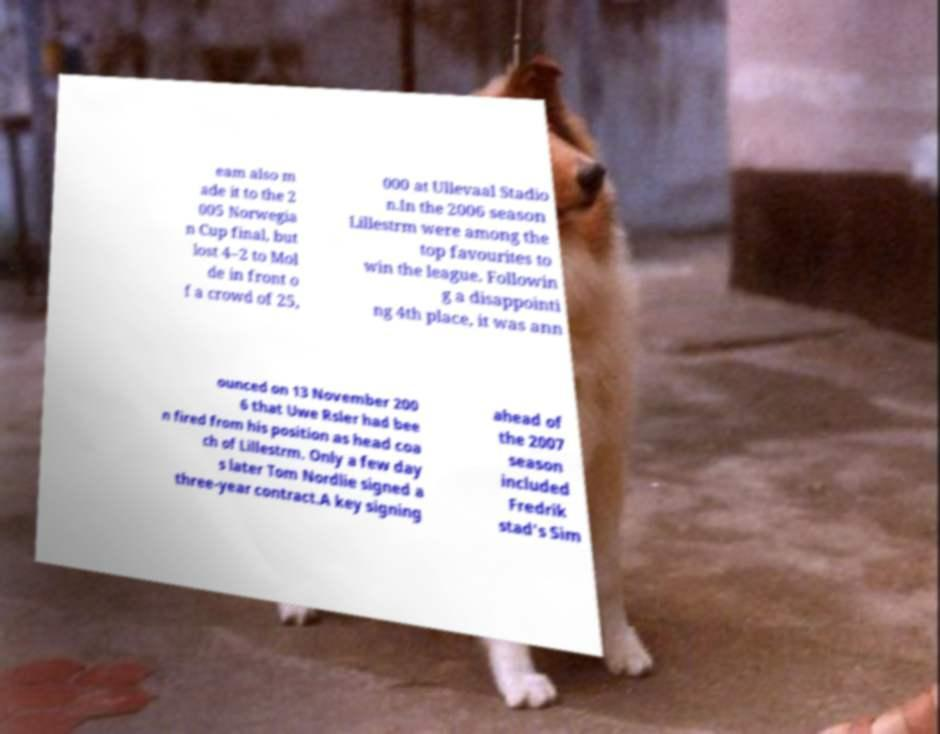Could you extract and type out the text from this image? eam also m ade it to the 2 005 Norwegia n Cup final, but lost 4–2 to Mol de in front o f a crowd of 25, 000 at Ullevaal Stadio n.In the 2006 season Lillestrm were among the top favourites to win the league. Followin g a disappointi ng 4th place, it was ann ounced on 13 November 200 6 that Uwe Rsler had bee n fired from his position as head coa ch of Lillestrm. Only a few day s later Tom Nordlie signed a three-year contract.A key signing ahead of the 2007 season included Fredrik stad's Sim 